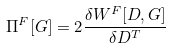Convert formula to latex. <formula><loc_0><loc_0><loc_500><loc_500>\Pi ^ { F } [ G ] = 2 \frac { \delta W ^ { F } [ D , G ] } { \delta D ^ { T } }</formula> 